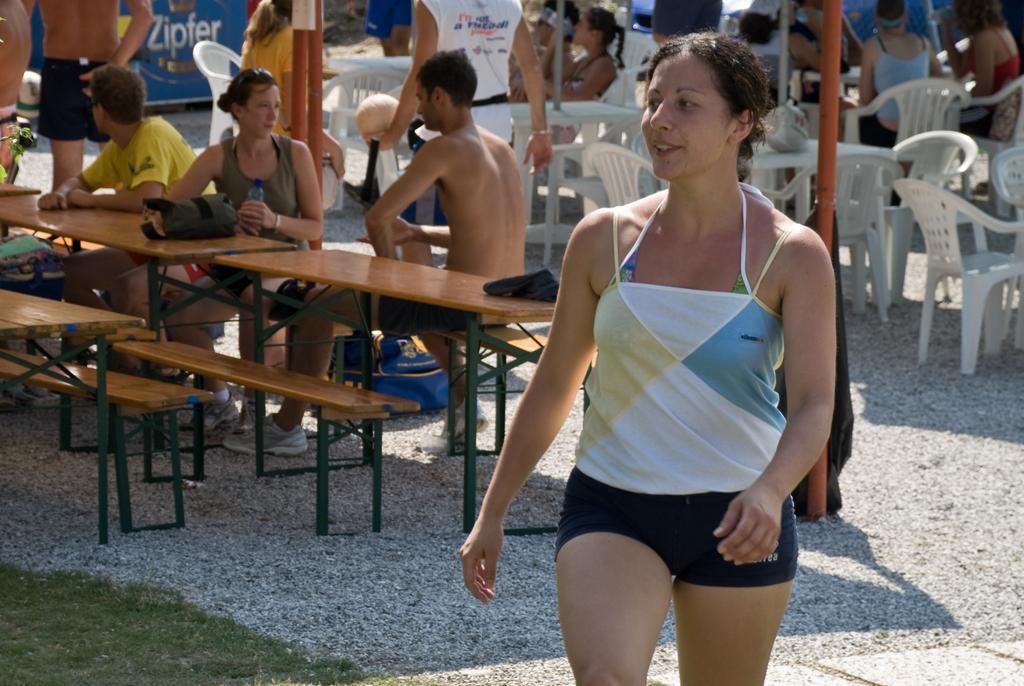Describe this image in one or two sentences. In this image I can see a person walking. In the background there are group of people sitting in-front of the table. On the table there are bags and a person holding a bottle. In the back there is a blue banner. 